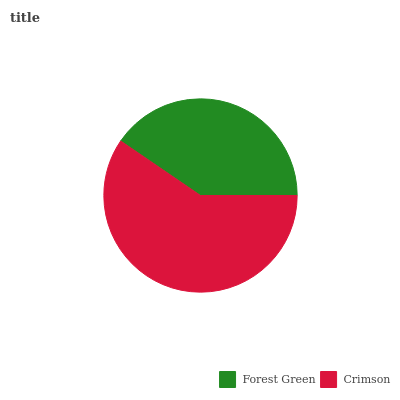Is Forest Green the minimum?
Answer yes or no. Yes. Is Crimson the maximum?
Answer yes or no. Yes. Is Crimson the minimum?
Answer yes or no. No. Is Crimson greater than Forest Green?
Answer yes or no. Yes. Is Forest Green less than Crimson?
Answer yes or no. Yes. Is Forest Green greater than Crimson?
Answer yes or no. No. Is Crimson less than Forest Green?
Answer yes or no. No. Is Crimson the high median?
Answer yes or no. Yes. Is Forest Green the low median?
Answer yes or no. Yes. Is Forest Green the high median?
Answer yes or no. No. Is Crimson the low median?
Answer yes or no. No. 